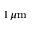<formula> <loc_0><loc_0><loc_500><loc_500>1 \, \mu \mathrm m</formula> 